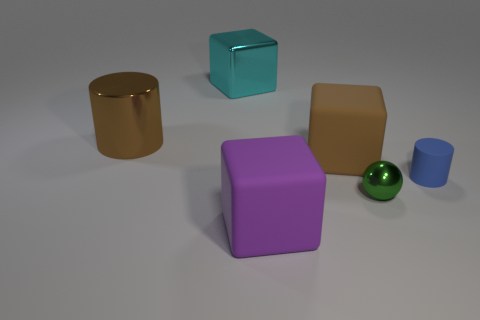Subtract all large brown blocks. How many blocks are left? 2 Subtract all brown cylinders. How many cylinders are left? 1 Subtract 1 balls. How many balls are left? 0 Subtract all spheres. How many objects are left? 5 Add 4 small green objects. How many objects exist? 10 Add 6 large blocks. How many large blocks are left? 9 Add 2 matte cylinders. How many matte cylinders exist? 3 Subtract 1 brown cubes. How many objects are left? 5 Subtract all brown cylinders. Subtract all green blocks. How many cylinders are left? 1 Subtract all cyan spheres. How many brown cylinders are left? 1 